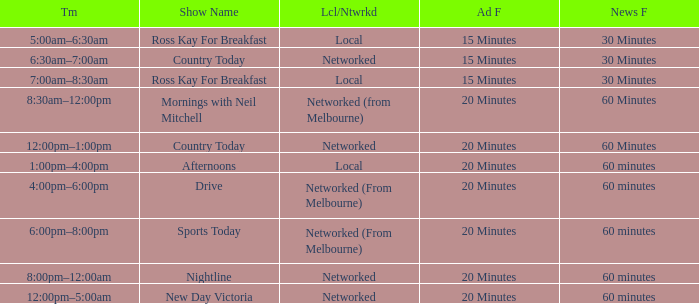What Time has a Show Name of mornings with neil mitchell? 8:30am–12:00pm. 